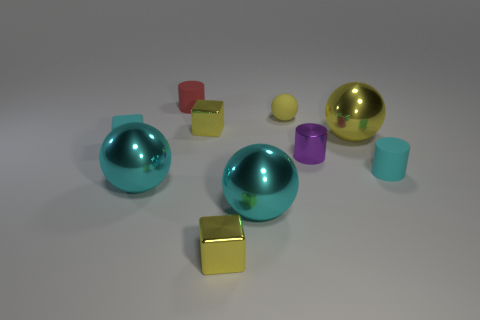Subtract all big yellow metallic spheres. How many spheres are left? 3 Subtract all yellow spheres. How many spheres are left? 2 Subtract all red cubes. How many yellow balls are left? 2 Subtract all cubes. How many objects are left? 7 Subtract 1 blocks. How many blocks are left? 2 Subtract all purple cubes. Subtract all brown cylinders. How many cubes are left? 3 Subtract all matte things. Subtract all cyan matte things. How many objects are left? 4 Add 3 small purple objects. How many small purple objects are left? 4 Add 5 small purple cylinders. How many small purple cylinders exist? 6 Subtract 0 red blocks. How many objects are left? 10 